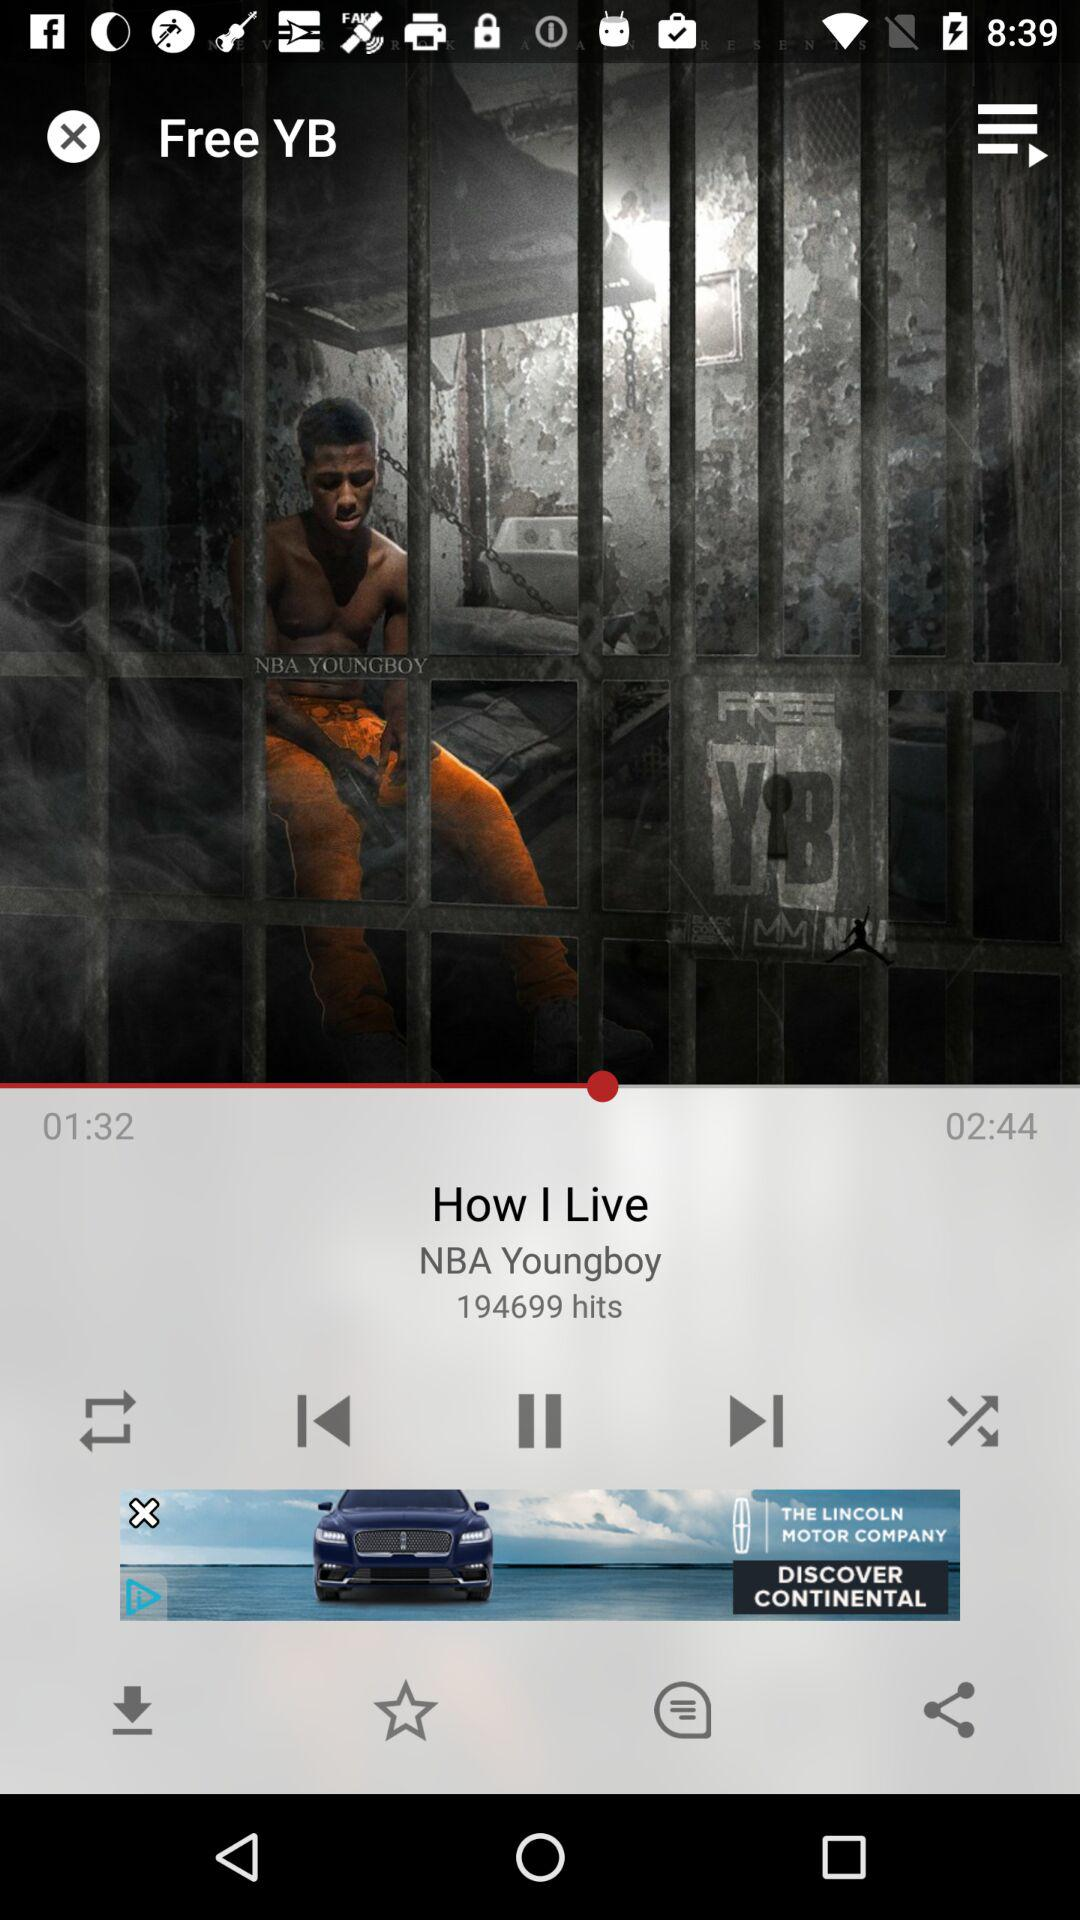How many hits are mentioned there? There are 194,699 mentioned hits. 